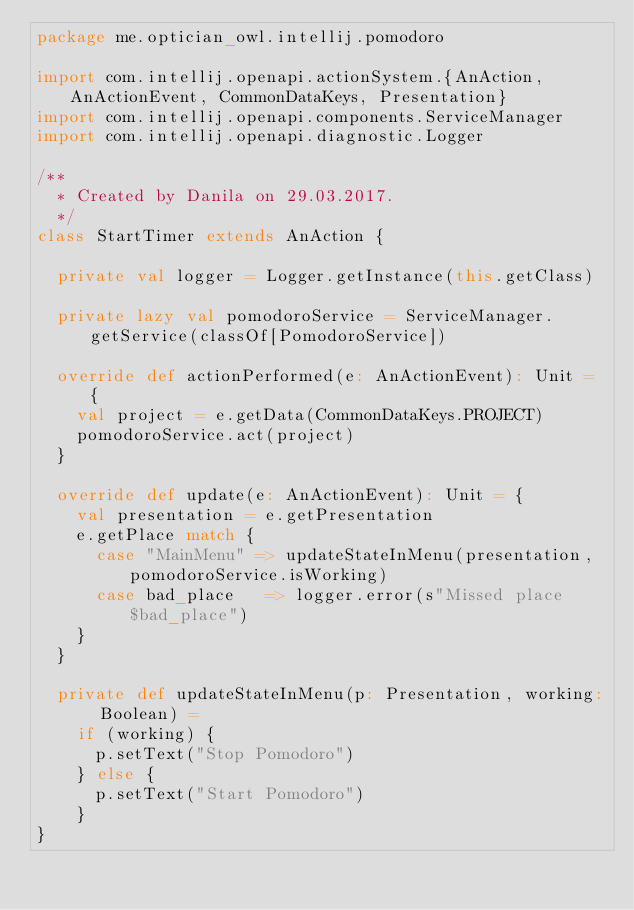Convert code to text. <code><loc_0><loc_0><loc_500><loc_500><_Scala_>package me.optician_owl.intellij.pomodoro

import com.intellij.openapi.actionSystem.{AnAction, AnActionEvent, CommonDataKeys, Presentation}
import com.intellij.openapi.components.ServiceManager
import com.intellij.openapi.diagnostic.Logger

/**
  * Created by Danila on 29.03.2017.
  */
class StartTimer extends AnAction {

  private val logger = Logger.getInstance(this.getClass)

  private lazy val pomodoroService = ServiceManager.getService(classOf[PomodoroService])

  override def actionPerformed(e: AnActionEvent): Unit = {
    val project = e.getData(CommonDataKeys.PROJECT)
    pomodoroService.act(project)
  }

  override def update(e: AnActionEvent): Unit = {
    val presentation = e.getPresentation
    e.getPlace match {
      case "MainMenu" => updateStateInMenu(presentation, pomodoroService.isWorking)
      case bad_place   => logger.error(s"Missed place $bad_place")
    }
  }

  private def updateStateInMenu(p: Presentation, working: Boolean) =
    if (working) {
      p.setText("Stop Pomodoro")
    } else {
      p.setText("Start Pomodoro")
    }
}
</code> 